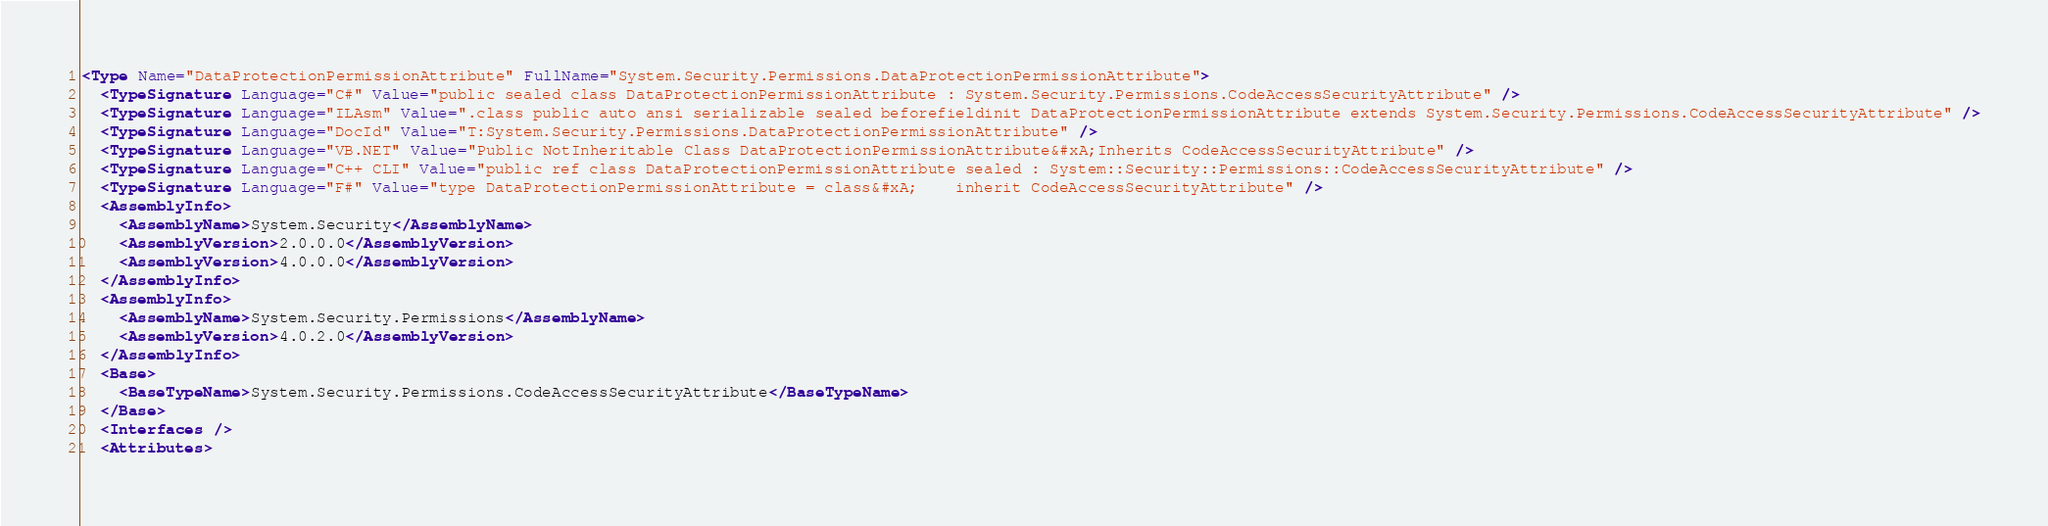Convert code to text. <code><loc_0><loc_0><loc_500><loc_500><_XML_><Type Name="DataProtectionPermissionAttribute" FullName="System.Security.Permissions.DataProtectionPermissionAttribute">
  <TypeSignature Language="C#" Value="public sealed class DataProtectionPermissionAttribute : System.Security.Permissions.CodeAccessSecurityAttribute" />
  <TypeSignature Language="ILAsm" Value=".class public auto ansi serializable sealed beforefieldinit DataProtectionPermissionAttribute extends System.Security.Permissions.CodeAccessSecurityAttribute" />
  <TypeSignature Language="DocId" Value="T:System.Security.Permissions.DataProtectionPermissionAttribute" />
  <TypeSignature Language="VB.NET" Value="Public NotInheritable Class DataProtectionPermissionAttribute&#xA;Inherits CodeAccessSecurityAttribute" />
  <TypeSignature Language="C++ CLI" Value="public ref class DataProtectionPermissionAttribute sealed : System::Security::Permissions::CodeAccessSecurityAttribute" />
  <TypeSignature Language="F#" Value="type DataProtectionPermissionAttribute = class&#xA;    inherit CodeAccessSecurityAttribute" />
  <AssemblyInfo>
    <AssemblyName>System.Security</AssemblyName>
    <AssemblyVersion>2.0.0.0</AssemblyVersion>
    <AssemblyVersion>4.0.0.0</AssemblyVersion>
  </AssemblyInfo>
  <AssemblyInfo>
    <AssemblyName>System.Security.Permissions</AssemblyName>
    <AssemblyVersion>4.0.2.0</AssemblyVersion>
  </AssemblyInfo>
  <Base>
    <BaseTypeName>System.Security.Permissions.CodeAccessSecurityAttribute</BaseTypeName>
  </Base>
  <Interfaces />
  <Attributes></code> 